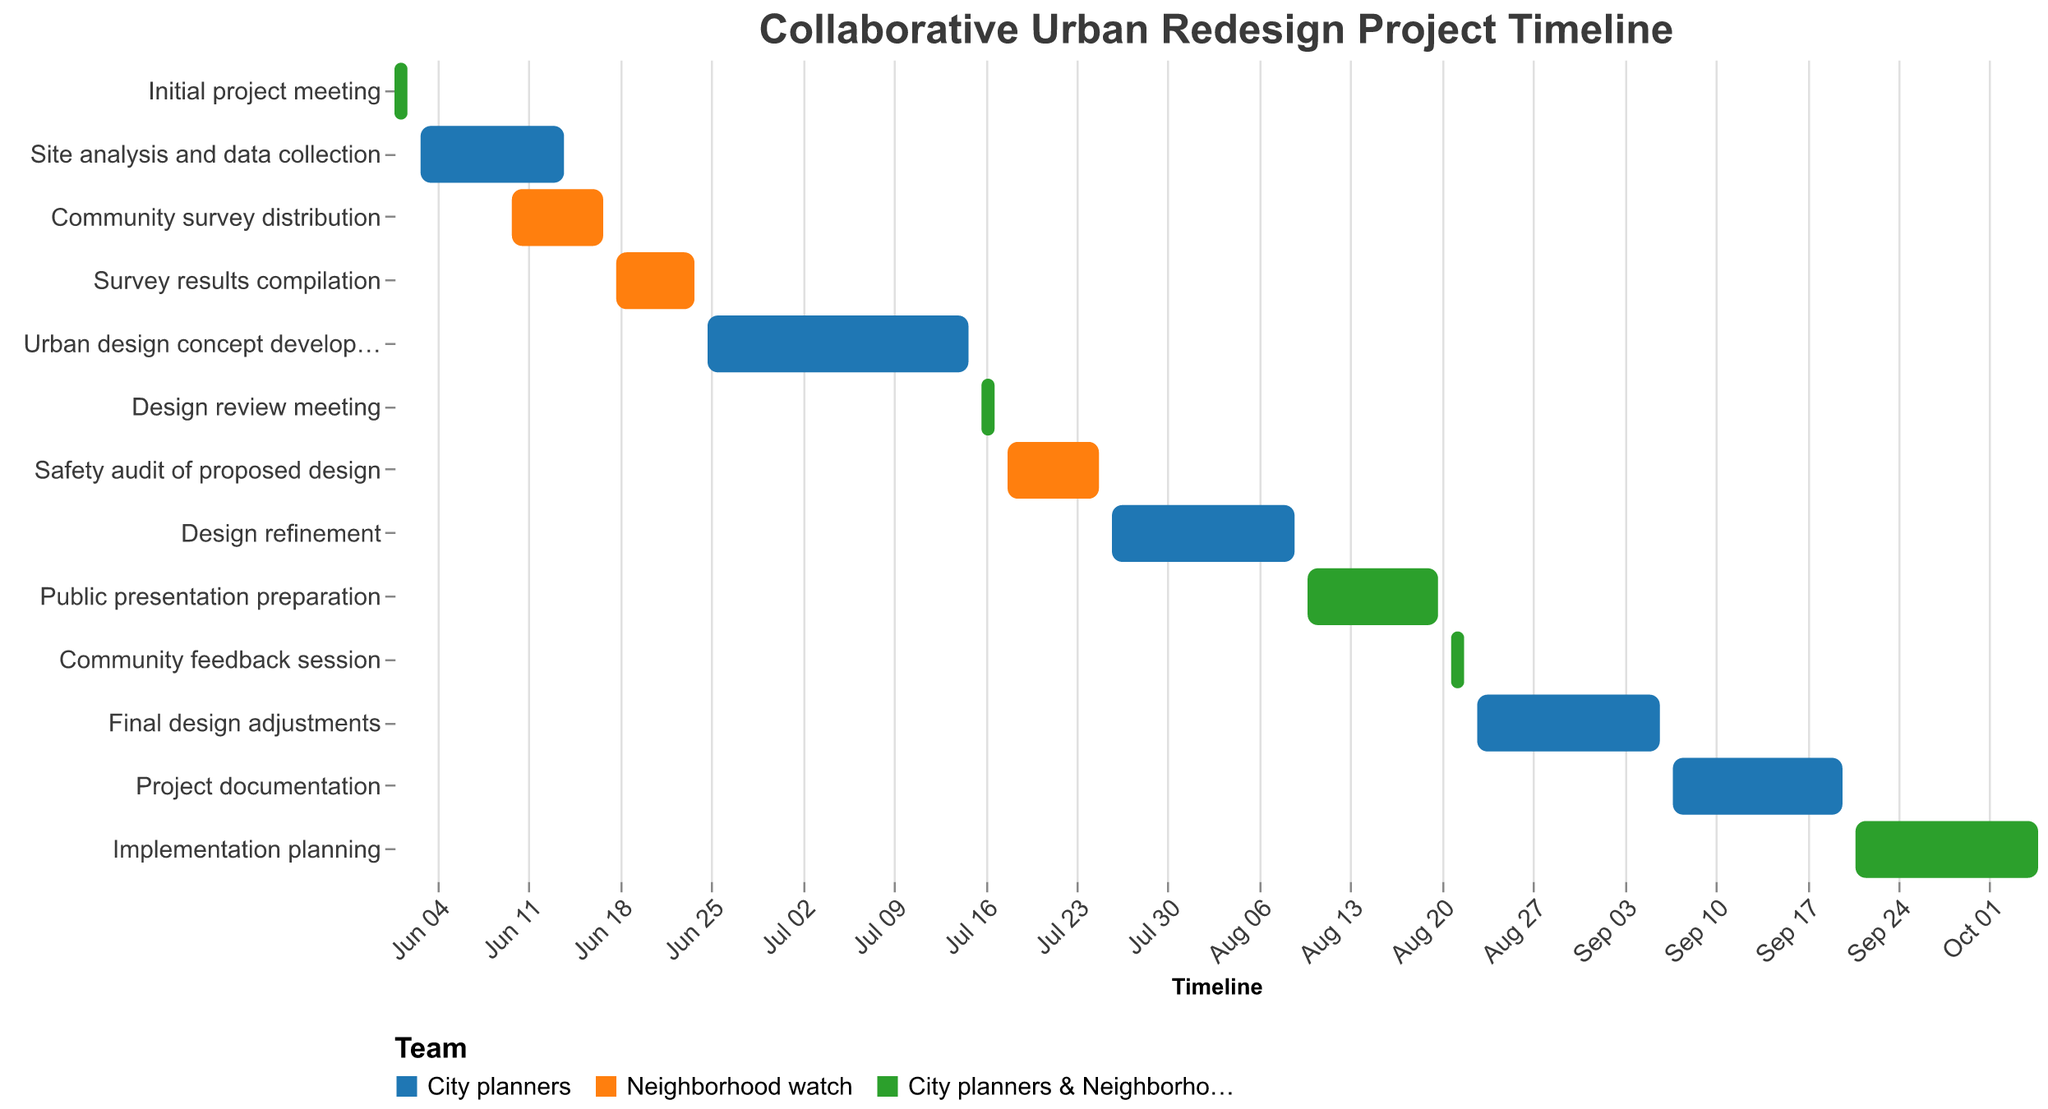What is the first task in the project according to the Gantt Chart? The first task in the Gantt Chart is the earliest starting task, which is "Initial project meeting."
Answer: Initial project meeting Which task takes place between June 3rd and June 14th? The task that fits this date range is "Site analysis and data collection" from June 3, 2023, to June 14, 2023.
Answer: Site analysis and data collection How many tasks involve both city planners and neighborhood watch volunteers? By observing the color coding and resources listed, there are five tasks involving both groups: "Initial project meeting," "Design review meeting," "Public presentation preparation," "Community feedback session," and "Implementation planning."
Answer: Five What is the longest task duration-wise, and how long does it last? The longest task is "Implementation planning," spanning from September 21, 2023, to October 5, 2023. It lasts for 15 days.
Answer: Implementation planning, 15 days Which tasks overlap with the "Community survey distribution"? The tasks overlapping with "Community survey distribution" (June 10, 2023, to June 17, 2023) are "Site analysis and data collection" and "Survey results compilation."
Answer: Site analysis and data collection and Survey results compilation What is the duration of "Urban design concept development"? "Urban design concept development" starts on June 25, 2023, and ends on July 15, 2023, lasting for 21 days.
Answer: 21 days Which team is responsible for the "Safety audit of proposed design" and when does it happen? The "Safety audit of proposed design" is conducted by the Neighborhood watch from July 18, 2023, to July 25, 2023.
Answer: Neighborhood watch, July 18 to July 25 At what point does "Project documentation" start in the timeline, and who is responsible for it? "Project documentation" starts on September 7, 2023, and it is the responsibility of the City planners.
Answer: September 7, City planners 